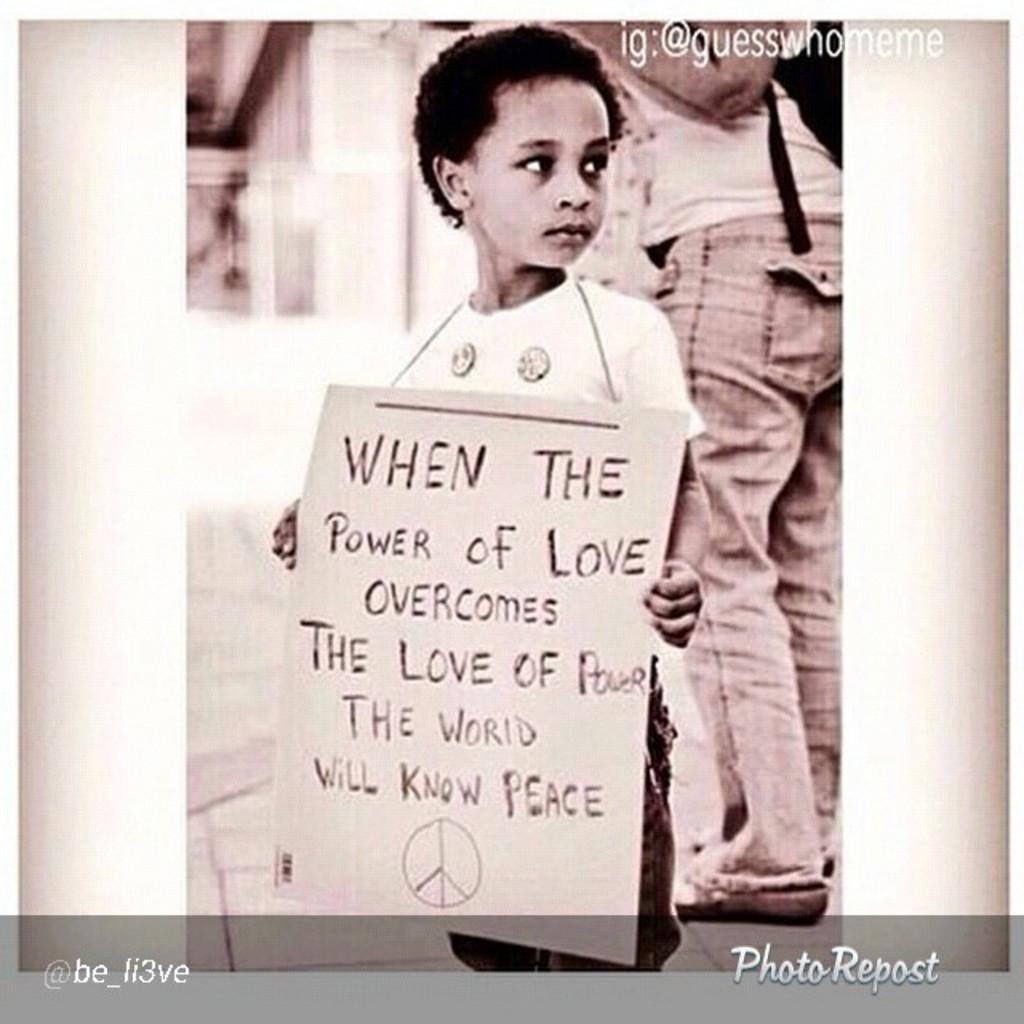What is the main subject of the image? The main subject of the image is a kid. What is the kid holding in the image? The kid is holding a placard in the image. Can you describe the person in the background of the image? There is a person standing in the background of the image, and they are standing on the floor. What type of railway can be seen in the image? There is no railway present in the image. How many flowers are visible in the image? There are no flowers visible in the image. 